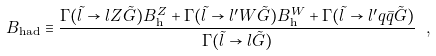Convert formula to latex. <formula><loc_0><loc_0><loc_500><loc_500>B _ { \text {had} } \equiv \frac { \Gamma ( \tilde { l } \to l Z \tilde { G } ) B _ { \text {h} } ^ { Z } + \Gamma ( \tilde { l } \to l ^ { \prime } W \tilde { G } ) B _ { \text {h} } ^ { W } + \Gamma ( \tilde { l } \to l ^ { \prime } q \bar { q } \tilde { G } ) } { \Gamma ( \tilde { l } \to l \tilde { G } ) } \ ,</formula> 